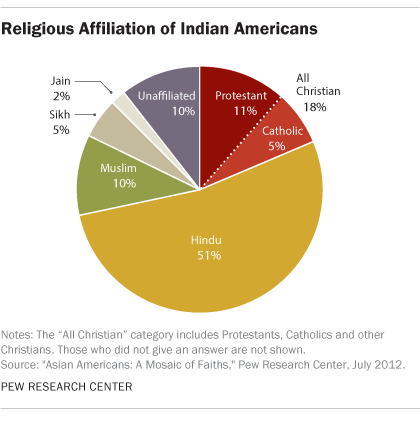Mention a couple of crucial points in this snapshot. What is the percentage value of Muslims? It is approximately 10%. The ratio of Catholic and Muslim populations is approximately 0.043055556. 